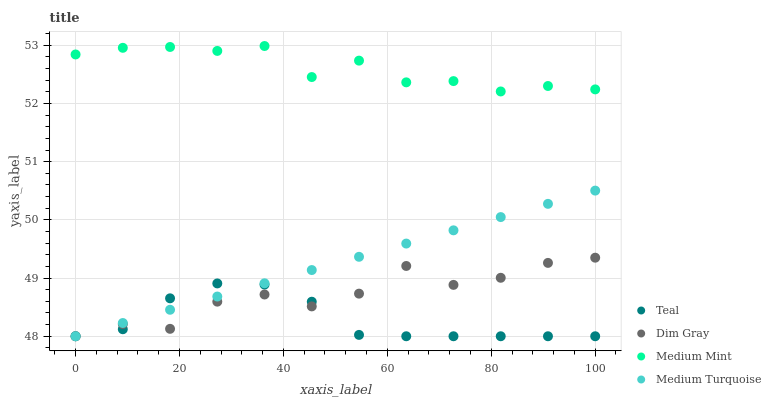Does Teal have the minimum area under the curve?
Answer yes or no. Yes. Does Medium Mint have the maximum area under the curve?
Answer yes or no. Yes. Does Dim Gray have the minimum area under the curve?
Answer yes or no. No. Does Dim Gray have the maximum area under the curve?
Answer yes or no. No. Is Medium Turquoise the smoothest?
Answer yes or no. Yes. Is Dim Gray the roughest?
Answer yes or no. Yes. Is Dim Gray the smoothest?
Answer yes or no. No. Is Medium Turquoise the roughest?
Answer yes or no. No. Does Dim Gray have the lowest value?
Answer yes or no. Yes. Does Medium Mint have the highest value?
Answer yes or no. Yes. Does Dim Gray have the highest value?
Answer yes or no. No. Is Medium Turquoise less than Medium Mint?
Answer yes or no. Yes. Is Medium Mint greater than Medium Turquoise?
Answer yes or no. Yes. Does Medium Turquoise intersect Teal?
Answer yes or no. Yes. Is Medium Turquoise less than Teal?
Answer yes or no. No. Is Medium Turquoise greater than Teal?
Answer yes or no. No. Does Medium Turquoise intersect Medium Mint?
Answer yes or no. No. 